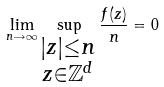<formula> <loc_0><loc_0><loc_500><loc_500>\lim _ { n \rightarrow \infty } \sup _ { \substack { | z | \leq n \\ z \in \mathbb { Z } ^ { d } } } \frac { f ( z ) } { n } = 0</formula> 